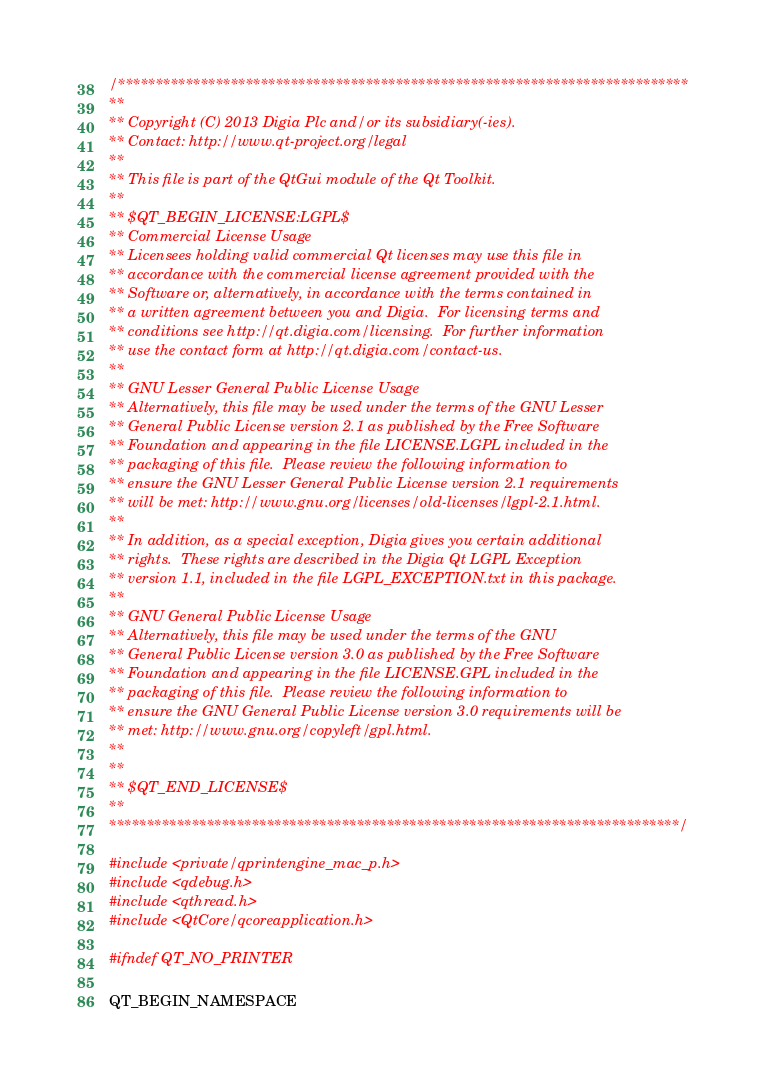Convert code to text. <code><loc_0><loc_0><loc_500><loc_500><_ObjectiveC_>/****************************************************************************
**
** Copyright (C) 2013 Digia Plc and/or its subsidiary(-ies).
** Contact: http://www.qt-project.org/legal
**
** This file is part of the QtGui module of the Qt Toolkit.
**
** $QT_BEGIN_LICENSE:LGPL$
** Commercial License Usage
** Licensees holding valid commercial Qt licenses may use this file in
** accordance with the commercial license agreement provided with the
** Software or, alternatively, in accordance with the terms contained in
** a written agreement between you and Digia.  For licensing terms and
** conditions see http://qt.digia.com/licensing.  For further information
** use the contact form at http://qt.digia.com/contact-us.
**
** GNU Lesser General Public License Usage
** Alternatively, this file may be used under the terms of the GNU Lesser
** General Public License version 2.1 as published by the Free Software
** Foundation and appearing in the file LICENSE.LGPL included in the
** packaging of this file.  Please review the following information to
** ensure the GNU Lesser General Public License version 2.1 requirements
** will be met: http://www.gnu.org/licenses/old-licenses/lgpl-2.1.html.
**
** In addition, as a special exception, Digia gives you certain additional
** rights.  These rights are described in the Digia Qt LGPL Exception
** version 1.1, included in the file LGPL_EXCEPTION.txt in this package.
**
** GNU General Public License Usage
** Alternatively, this file may be used under the terms of the GNU
** General Public License version 3.0 as published by the Free Software
** Foundation and appearing in the file LICENSE.GPL included in the
** packaging of this file.  Please review the following information to
** ensure the GNU General Public License version 3.0 requirements will be
** met: http://www.gnu.org/copyleft/gpl.html.
**
**
** $QT_END_LICENSE$
**
****************************************************************************/

#include <private/qprintengine_mac_p.h>
#include <qdebug.h>
#include <qthread.h>
#include <QtCore/qcoreapplication.h>

#ifndef QT_NO_PRINTER

QT_BEGIN_NAMESPACE
</code> 